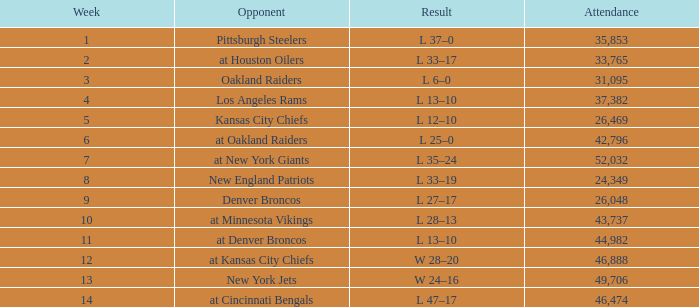What is the highest Week when the opponent was kansas city chiefs, with more than 26,469 in attendance? None. Write the full table. {'header': ['Week', 'Opponent', 'Result', 'Attendance'], 'rows': [['1', 'Pittsburgh Steelers', 'L 37–0', '35,853'], ['2', 'at Houston Oilers', 'L 33–17', '33,765'], ['3', 'Oakland Raiders', 'L 6–0', '31,095'], ['4', 'Los Angeles Rams', 'L 13–10', '37,382'], ['5', 'Kansas City Chiefs', 'L 12–10', '26,469'], ['6', 'at Oakland Raiders', 'L 25–0', '42,796'], ['7', 'at New York Giants', 'L 35–24', '52,032'], ['8', 'New England Patriots', 'L 33–19', '24,349'], ['9', 'Denver Broncos', 'L 27–17', '26,048'], ['10', 'at Minnesota Vikings', 'L 28–13', '43,737'], ['11', 'at Denver Broncos', 'L 13–10', '44,982'], ['12', 'at Kansas City Chiefs', 'W 28–20', '46,888'], ['13', 'New York Jets', 'W 24–16', '49,706'], ['14', 'at Cincinnati Bengals', 'L 47–17', '46,474']]} 